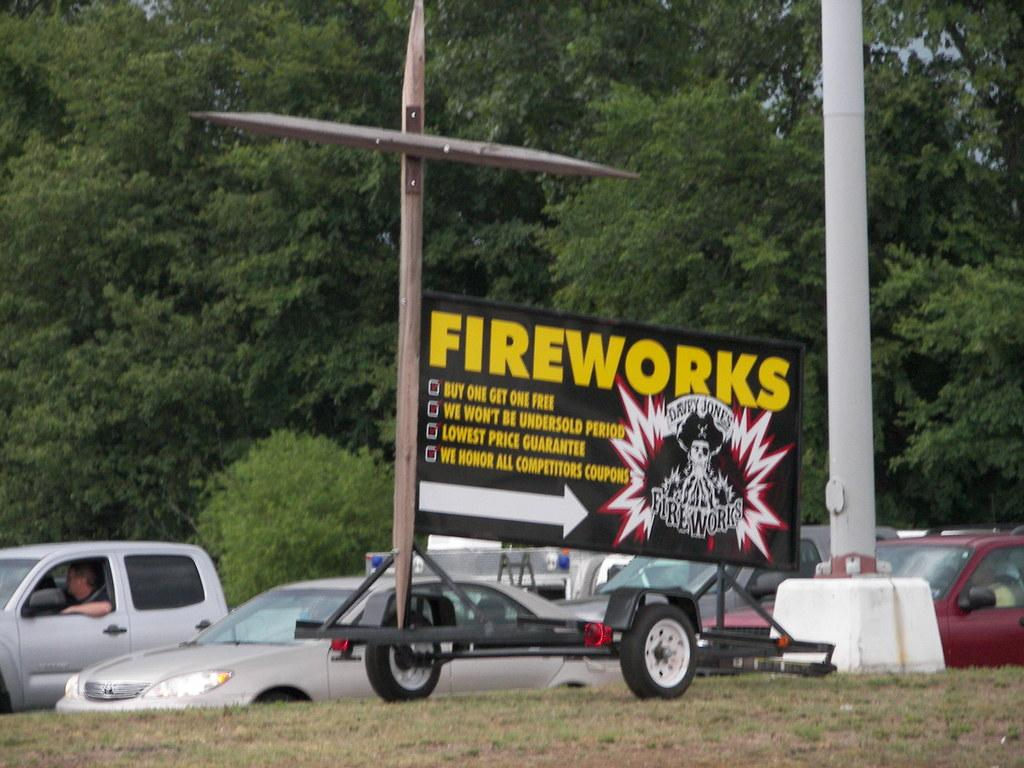What types of objects are present in the image? There are vehicles in the image. Can you describe the black object attached to a pole? There is a black color board attached to a pole in the image. What kind of vegetation is visible in the image? There are trees with green leaves in the image. What is the color of the sky in the image? The sky is blue in the image. How many bananas are hanging from the trees in the image? There are no bananas present in the image; the trees have green leaves. Can you tell me the name of the horse's owner in the image? There is no horse present in the image. 